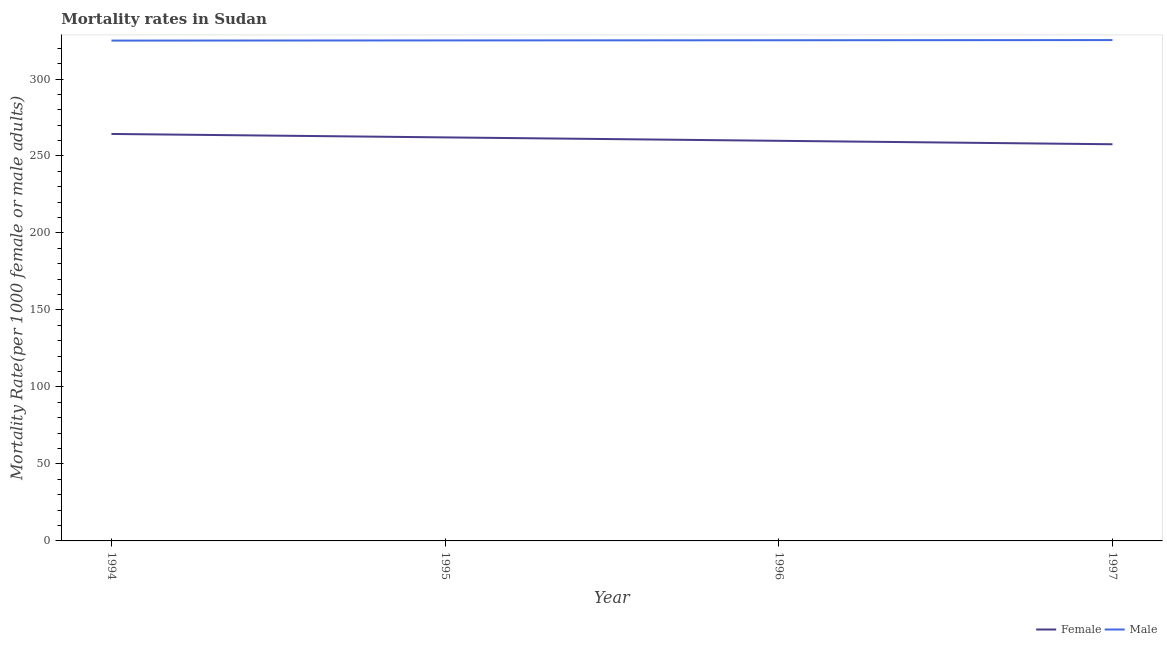What is the female mortality rate in 1996?
Offer a very short reply. 259.86. Across all years, what is the maximum female mortality rate?
Give a very brief answer. 264.31. Across all years, what is the minimum male mortality rate?
Ensure brevity in your answer.  324.95. In which year was the male mortality rate maximum?
Provide a short and direct response. 1997. What is the total male mortality rate in the graph?
Offer a very short reply. 1300.45. What is the difference between the female mortality rate in 1995 and that in 1997?
Your response must be concise. 4.45. What is the difference between the male mortality rate in 1996 and the female mortality rate in 1995?
Make the answer very short. 63.09. What is the average female mortality rate per year?
Your response must be concise. 260.97. In the year 1996, what is the difference between the male mortality rate and female mortality rate?
Offer a very short reply. 65.31. In how many years, is the female mortality rate greater than 250?
Offer a terse response. 4. What is the ratio of the female mortality rate in 1996 to that in 1997?
Offer a terse response. 1.01. Is the difference between the female mortality rate in 1996 and 1997 greater than the difference between the male mortality rate in 1996 and 1997?
Provide a succinct answer. Yes. What is the difference between the highest and the second highest male mortality rate?
Provide a short and direct response. 0.11. What is the difference between the highest and the lowest male mortality rate?
Make the answer very short. 0.33. Is the sum of the female mortality rate in 1994 and 1996 greater than the maximum male mortality rate across all years?
Your answer should be compact. Yes. Does the female mortality rate monotonically increase over the years?
Keep it short and to the point. No. Is the male mortality rate strictly greater than the female mortality rate over the years?
Make the answer very short. Yes. How many lines are there?
Provide a succinct answer. 2. How many years are there in the graph?
Provide a succinct answer. 4. What is the difference between two consecutive major ticks on the Y-axis?
Ensure brevity in your answer.  50. Does the graph contain any zero values?
Give a very brief answer. No. What is the title of the graph?
Offer a terse response. Mortality rates in Sudan. What is the label or title of the Y-axis?
Offer a terse response. Mortality Rate(per 1000 female or male adults). What is the Mortality Rate(per 1000 female or male adults) of Female in 1994?
Ensure brevity in your answer.  264.31. What is the Mortality Rate(per 1000 female or male adults) of Male in 1994?
Offer a terse response. 324.95. What is the Mortality Rate(per 1000 female or male adults) in Female in 1995?
Give a very brief answer. 262.08. What is the Mortality Rate(per 1000 female or male adults) of Male in 1995?
Give a very brief answer. 325.06. What is the Mortality Rate(per 1000 female or male adults) in Female in 1996?
Offer a very short reply. 259.86. What is the Mortality Rate(per 1000 female or male adults) of Male in 1996?
Offer a terse response. 325.17. What is the Mortality Rate(per 1000 female or male adults) in Female in 1997?
Provide a short and direct response. 257.63. What is the Mortality Rate(per 1000 female or male adults) of Male in 1997?
Offer a terse response. 325.28. Across all years, what is the maximum Mortality Rate(per 1000 female or male adults) in Female?
Give a very brief answer. 264.31. Across all years, what is the maximum Mortality Rate(per 1000 female or male adults) in Male?
Ensure brevity in your answer.  325.28. Across all years, what is the minimum Mortality Rate(per 1000 female or male adults) in Female?
Your response must be concise. 257.63. Across all years, what is the minimum Mortality Rate(per 1000 female or male adults) of Male?
Make the answer very short. 324.95. What is the total Mortality Rate(per 1000 female or male adults) in Female in the graph?
Give a very brief answer. 1043.87. What is the total Mortality Rate(per 1000 female or male adults) in Male in the graph?
Your answer should be very brief. 1300.45. What is the difference between the Mortality Rate(per 1000 female or male adults) of Female in 1994 and that in 1995?
Your answer should be compact. 2.23. What is the difference between the Mortality Rate(per 1000 female or male adults) of Male in 1994 and that in 1995?
Your answer should be compact. -0.11. What is the difference between the Mortality Rate(per 1000 female or male adults) in Female in 1994 and that in 1996?
Your response must be concise. 4.45. What is the difference between the Mortality Rate(per 1000 female or male adults) of Male in 1994 and that in 1996?
Offer a very short reply. -0.22. What is the difference between the Mortality Rate(per 1000 female or male adults) in Female in 1994 and that in 1997?
Your answer should be very brief. 6.68. What is the difference between the Mortality Rate(per 1000 female or male adults) of Male in 1994 and that in 1997?
Ensure brevity in your answer.  -0.33. What is the difference between the Mortality Rate(per 1000 female or male adults) in Female in 1995 and that in 1996?
Give a very brief answer. 2.23. What is the difference between the Mortality Rate(per 1000 female or male adults) of Male in 1995 and that in 1996?
Your answer should be very brief. -0.11. What is the difference between the Mortality Rate(per 1000 female or male adults) in Female in 1995 and that in 1997?
Ensure brevity in your answer.  4.45. What is the difference between the Mortality Rate(per 1000 female or male adults) in Male in 1995 and that in 1997?
Your answer should be compact. -0.22. What is the difference between the Mortality Rate(per 1000 female or male adults) of Female in 1996 and that in 1997?
Make the answer very short. 2.23. What is the difference between the Mortality Rate(per 1000 female or male adults) of Male in 1996 and that in 1997?
Offer a very short reply. -0.11. What is the difference between the Mortality Rate(per 1000 female or male adults) of Female in 1994 and the Mortality Rate(per 1000 female or male adults) of Male in 1995?
Offer a very short reply. -60.75. What is the difference between the Mortality Rate(per 1000 female or male adults) of Female in 1994 and the Mortality Rate(per 1000 female or male adults) of Male in 1996?
Provide a succinct answer. -60.86. What is the difference between the Mortality Rate(per 1000 female or male adults) in Female in 1994 and the Mortality Rate(per 1000 female or male adults) in Male in 1997?
Offer a very short reply. -60.97. What is the difference between the Mortality Rate(per 1000 female or male adults) in Female in 1995 and the Mortality Rate(per 1000 female or male adults) in Male in 1996?
Give a very brief answer. -63.09. What is the difference between the Mortality Rate(per 1000 female or male adults) in Female in 1995 and the Mortality Rate(per 1000 female or male adults) in Male in 1997?
Offer a very short reply. -63.2. What is the difference between the Mortality Rate(per 1000 female or male adults) of Female in 1996 and the Mortality Rate(per 1000 female or male adults) of Male in 1997?
Provide a succinct answer. -65.42. What is the average Mortality Rate(per 1000 female or male adults) in Female per year?
Provide a succinct answer. 260.97. What is the average Mortality Rate(per 1000 female or male adults) of Male per year?
Make the answer very short. 325.11. In the year 1994, what is the difference between the Mortality Rate(per 1000 female or male adults) of Female and Mortality Rate(per 1000 female or male adults) of Male?
Offer a terse response. -60.64. In the year 1995, what is the difference between the Mortality Rate(per 1000 female or male adults) in Female and Mortality Rate(per 1000 female or male adults) in Male?
Keep it short and to the point. -62.98. In the year 1996, what is the difference between the Mortality Rate(per 1000 female or male adults) in Female and Mortality Rate(per 1000 female or male adults) in Male?
Provide a short and direct response. -65.31. In the year 1997, what is the difference between the Mortality Rate(per 1000 female or male adults) of Female and Mortality Rate(per 1000 female or male adults) of Male?
Make the answer very short. -67.65. What is the ratio of the Mortality Rate(per 1000 female or male adults) in Female in 1994 to that in 1995?
Make the answer very short. 1.01. What is the ratio of the Mortality Rate(per 1000 female or male adults) of Male in 1994 to that in 1995?
Provide a short and direct response. 1. What is the ratio of the Mortality Rate(per 1000 female or male adults) in Female in 1994 to that in 1996?
Offer a terse response. 1.02. What is the ratio of the Mortality Rate(per 1000 female or male adults) in Male in 1994 to that in 1996?
Offer a terse response. 1. What is the ratio of the Mortality Rate(per 1000 female or male adults) in Female in 1994 to that in 1997?
Your answer should be compact. 1.03. What is the ratio of the Mortality Rate(per 1000 female or male adults) of Female in 1995 to that in 1996?
Provide a short and direct response. 1.01. What is the ratio of the Mortality Rate(per 1000 female or male adults) in Female in 1995 to that in 1997?
Provide a succinct answer. 1.02. What is the ratio of the Mortality Rate(per 1000 female or male adults) in Male in 1995 to that in 1997?
Ensure brevity in your answer.  1. What is the ratio of the Mortality Rate(per 1000 female or male adults) in Female in 1996 to that in 1997?
Ensure brevity in your answer.  1.01. What is the difference between the highest and the second highest Mortality Rate(per 1000 female or male adults) in Female?
Your answer should be very brief. 2.23. What is the difference between the highest and the second highest Mortality Rate(per 1000 female or male adults) of Male?
Provide a short and direct response. 0.11. What is the difference between the highest and the lowest Mortality Rate(per 1000 female or male adults) in Female?
Ensure brevity in your answer.  6.68. What is the difference between the highest and the lowest Mortality Rate(per 1000 female or male adults) of Male?
Make the answer very short. 0.33. 